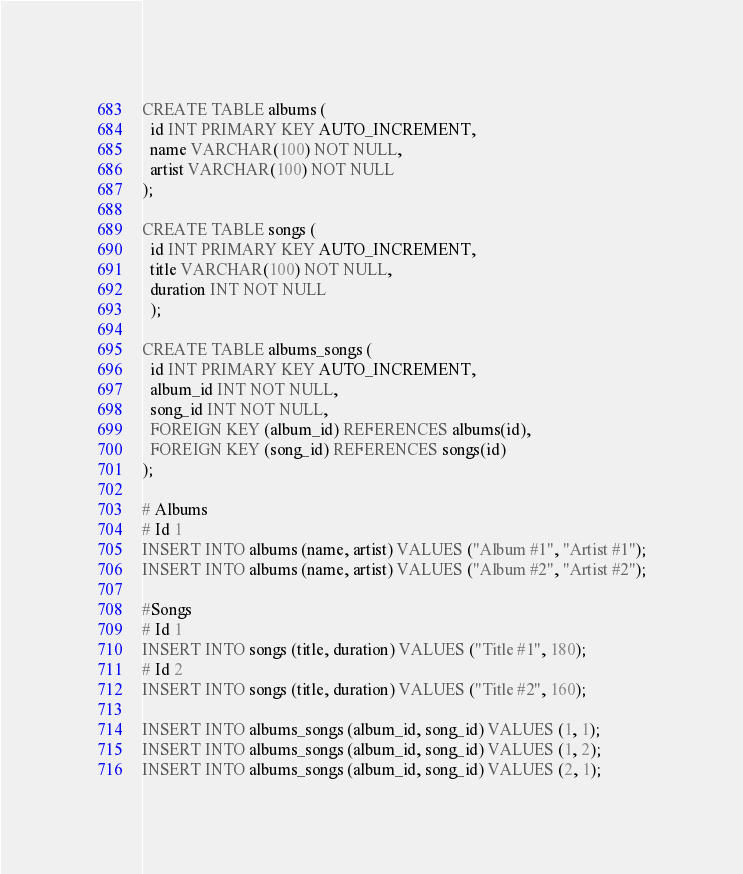<code> <loc_0><loc_0><loc_500><loc_500><_SQL_>CREATE TABLE albums (
  id INT PRIMARY KEY AUTO_INCREMENT,
  name VARCHAR(100) NOT NULL,
  artist VARCHAR(100) NOT NULL
);

CREATE TABLE songs (
  id INT PRIMARY KEY AUTO_INCREMENT,
  title VARCHAR(100) NOT NULL,
  duration INT NOT NULL
  );

CREATE TABLE albums_songs (
  id INT PRIMARY KEY AUTO_INCREMENT,
  album_id INT NOT NULL,
  song_id INT NOT NULL,
  FOREIGN KEY (album_id) REFERENCES albums(id),
  FOREIGN KEY (song_id) REFERENCES songs(id)
);

# Albums
# Id 1
INSERT INTO albums (name, artist) VALUES ("Album #1", "Artist #1");
INSERT INTO albums (name, artist) VALUES ("Album #2", "Artist #2");

#Songs
# Id 1
INSERT INTO songs (title, duration) VALUES ("Title #1", 180);
# Id 2
INSERT INTO songs (title, duration) VALUES ("Title #2", 160);

INSERT INTO albums_songs (album_id, song_id) VALUES (1, 1);
INSERT INTO albums_songs (album_id, song_id) VALUES (1, 2);
INSERT INTO albums_songs (album_id, song_id) VALUES (2, 1);
</code> 